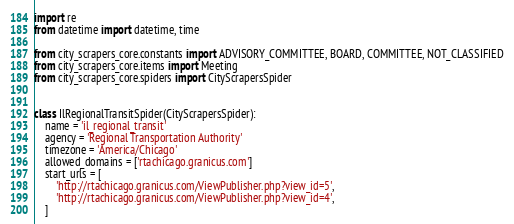<code> <loc_0><loc_0><loc_500><loc_500><_Python_>import re
from datetime import datetime, time

from city_scrapers_core.constants import ADVISORY_COMMITTEE, BOARD, COMMITTEE, NOT_CLASSIFIED
from city_scrapers_core.items import Meeting
from city_scrapers_core.spiders import CityScrapersSpider


class IlRegionalTransitSpider(CityScrapersSpider):
    name = 'il_regional_transit'
    agency = 'Regional Transportation Authority'
    timezone = 'America/Chicago'
    allowed_domains = ['rtachicago.granicus.com']
    start_urls = [
        'http://rtachicago.granicus.com/ViewPublisher.php?view_id=5',
        'http://rtachicago.granicus.com/ViewPublisher.php?view_id=4',
    ]</code> 